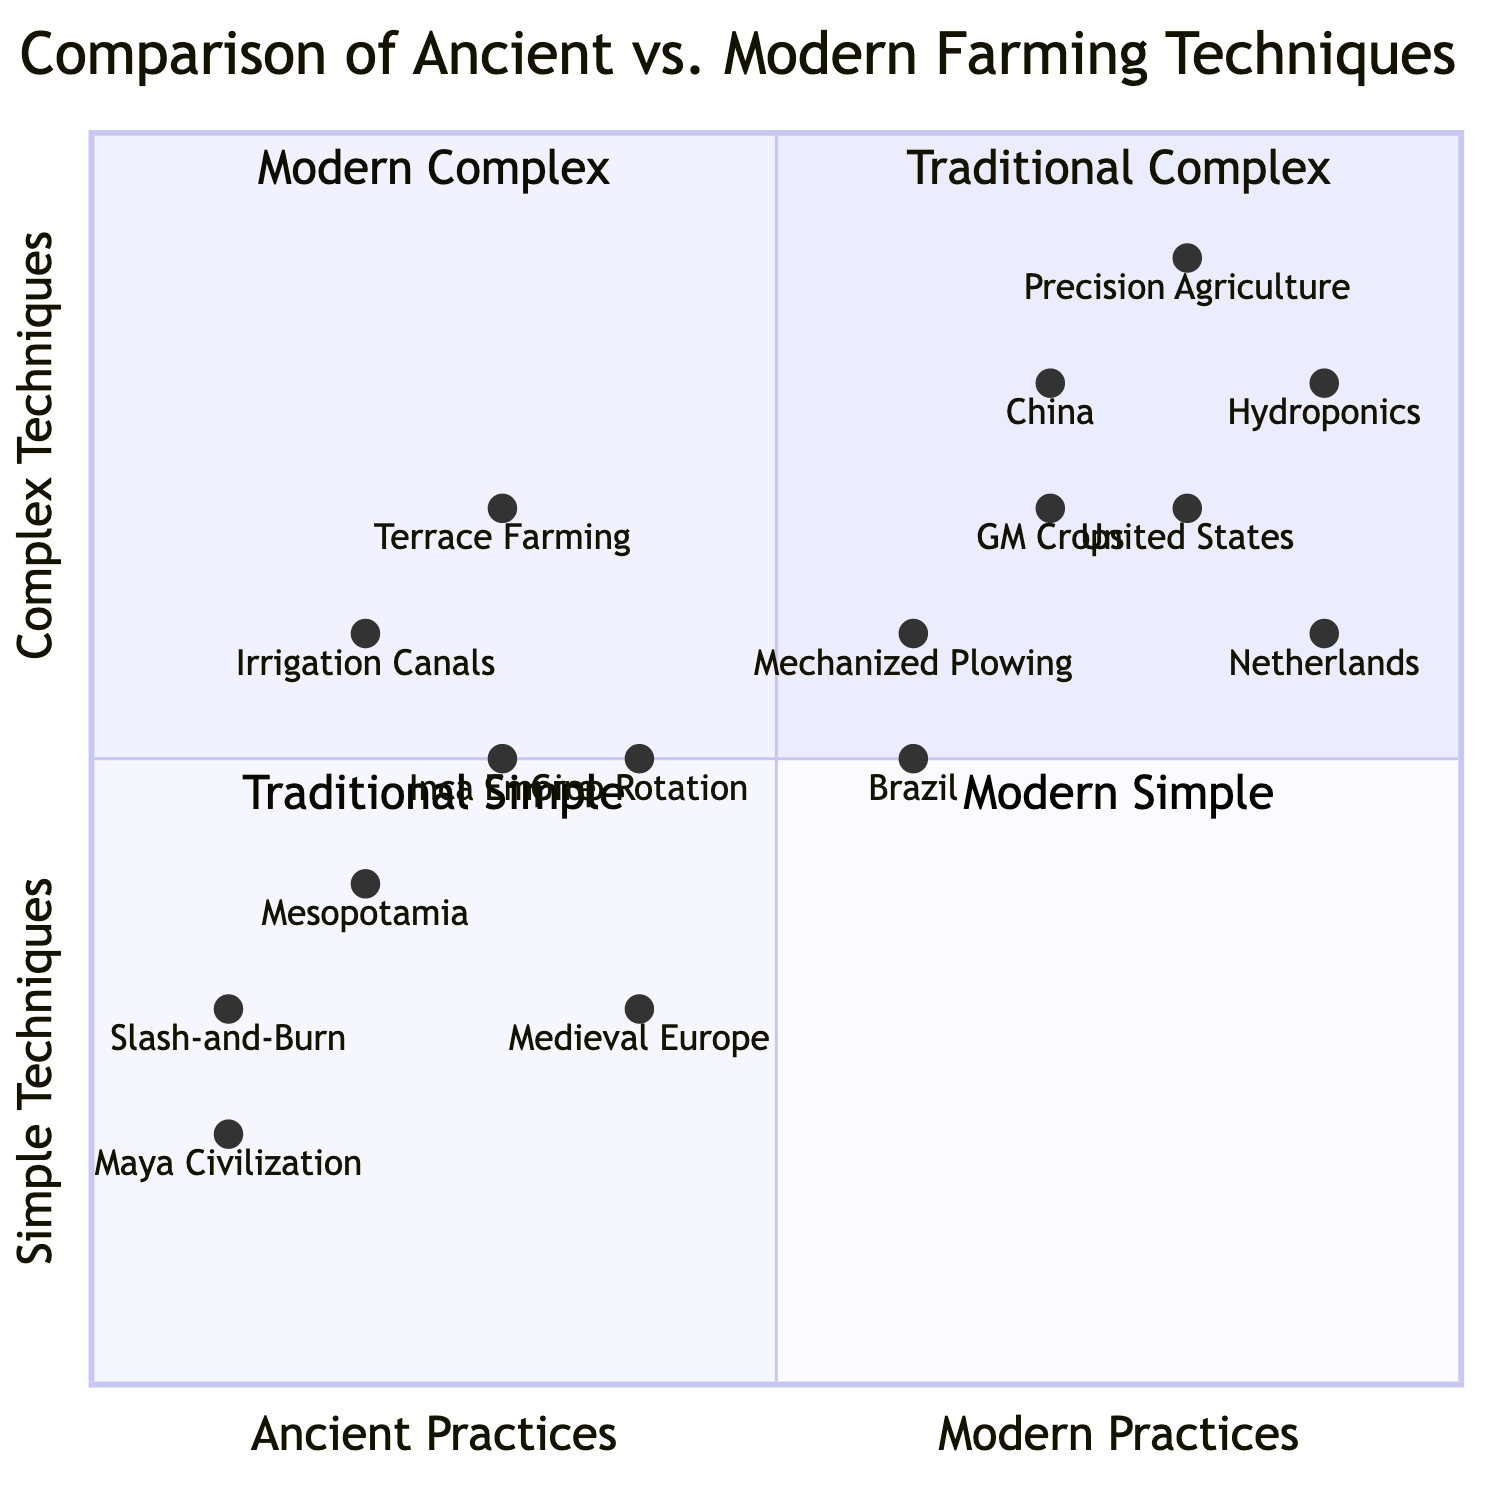What civilization is represented at the coordinates (0.2, 0.4)? At the coordinates (0.2, 0.4) in the quadrant chart, the point corresponds to Mesopotamia, as indicated by its position relative to the x-axis (Ancient Practices) and y-axis (Simple Techniques).
Answer: Mesopotamia Which farming technique is the most complex modern method according to the diagram? The point representing Hydroponics is located highest up in the quadrant at (0.9, 0.8), indicating that it is the most complex modern farming method when compared with the others on the chart.
Answer: Hydroponics How many ancient farming techniques are classified as simple in the diagram? The quadrant shows that only one ancient farming technique, namely Slash-and-Burn Agriculture, is in the lower right section of the diagram, which indicates that it is considered a simple technique.
Answer: One Which ancient civilization employed Terrace Farming? The coordinates for Terrace Farming are (0.3, 0.7), and by looking at the y-axis, it correlates directly with the Inca Empire located at (0.3, 0.5), thus indicating that the Inca Empire is the civilization employing Terrace Farming.
Answer: Inca Empire What is the average complexity score for modern farming techniques listed in the chart? The complexity scores for modern farming techniques are: Precision Agriculture (0.9), Hydroponics (0.8), GM Crops (0.7), and Mechanized Plowing (0.6). Calculating the average: (0.9 + 0.8 + 0.7 + 0.6) / 4 = 0.75.
Answer: 0.75 Which farming technique has the same complexity level as GM Crops? The coordinates for GM Crops are (0.7, 0.7), and looking at the chart, this complexity is matched by China, which is also plotted at (0.7, 0.8).
Answer: China What percentage of the ancient techniques are categorized as complex in the diagram? Of the four ancient farming techniques, three (Irrigation Canals, Terrace Farming, Crop Rotation) are classified as complex while only one (Slash-and-Burn Agriculture) is simple. Thus, the percentage of complex techniques is 75%.
Answer: 75% How many total farming techniques are represented in the diagram? The diagram includes a total of eight distinct farming techniques (four ancient and four modern). This is simply a count of the techniques listed in the data.
Answer: Eight Which farming technique is positioned closest to the Modern Simple quadrant? Mechanized Plowing, represented by the coordinates (0.6, 0.6), is positioned nearest to the Modern Simple quadrant compared to all other modern techniques.
Answer: Mechanized Plowing 